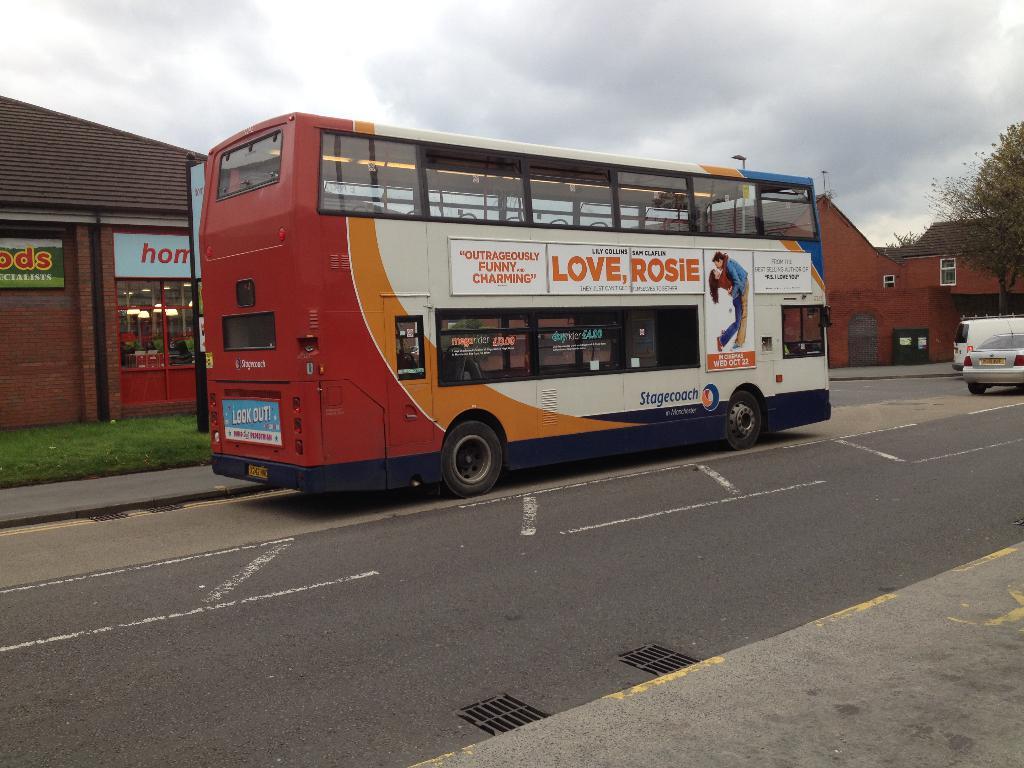What woman's name is on the bus?
Your answer should be very brief. Rosie. 